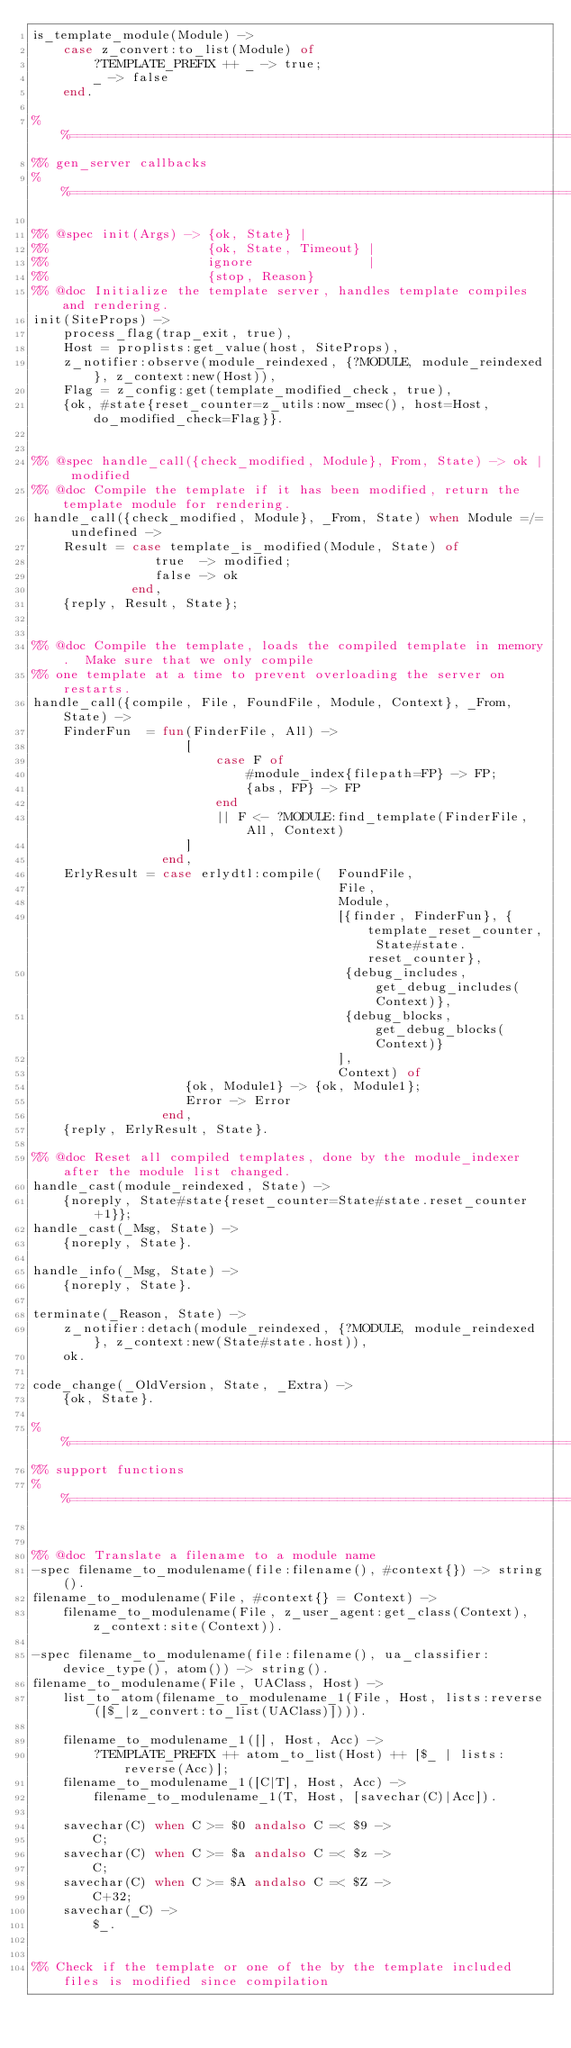<code> <loc_0><loc_0><loc_500><loc_500><_Erlang_>is_template_module(Module) ->
    case z_convert:to_list(Module) of
        ?TEMPLATE_PREFIX ++ _ -> true;
        _ -> false
    end.

%%====================================================================
%% gen_server callbacks
%%====================================================================

%% @spec init(Args) -> {ok, State} |
%%                     {ok, State, Timeout} |
%%                     ignore               |
%%                     {stop, Reason}
%% @doc Initialize the template server, handles template compiles and rendering.
init(SiteProps) ->
    process_flag(trap_exit, true),
    Host = proplists:get_value(host, SiteProps),
    z_notifier:observe(module_reindexed, {?MODULE, module_reindexed}, z_context:new(Host)),
    Flag = z_config:get(template_modified_check, true),
    {ok, #state{reset_counter=z_utils:now_msec(), host=Host, do_modified_check=Flag}}.


%% @spec handle_call({check_modified, Module}, From, State) -> ok | modified
%% @doc Compile the template if it has been modified, return the template module for rendering.
handle_call({check_modified, Module}, _From, State) when Module =/= undefined ->
    Result = case template_is_modified(Module, State) of
                true  -> modified;
                false -> ok
             end,
    {reply, Result, State};


%% @doc Compile the template, loads the compiled template in memory.  Make sure that we only compile 
%% one template at a time to prevent overloading the server on restarts.
handle_call({compile, File, FoundFile, Module, Context}, _From, State) ->
    FinderFun  = fun(FinderFile, All) ->
                    [
                        case F of
                            #module_index{filepath=FP} -> FP;
                            {abs, FP} -> FP
                        end
                        || F <- ?MODULE:find_template(FinderFile, All, Context)
                    ]
                 end,
    ErlyResult = case erlydtl:compile(  FoundFile,
                                        File,
                                        Module, 
                                        [{finder, FinderFun}, {template_reset_counter, State#state.reset_counter},
                                         {debug_includes, get_debug_includes(Context)},
                                         {debug_blocks, get_debug_blocks(Context)}
                                        ],
                                        Context) of
                    {ok, Module1} -> {ok, Module1};
                    Error -> Error
                 end,
    {reply, ErlyResult, State}.

%% @doc Reset all compiled templates, done by the module_indexer after the module list changed.
handle_cast(module_reindexed, State) -> 
    {noreply, State#state{reset_counter=State#state.reset_counter+1}};
handle_cast(_Msg, State) -> 
    {noreply, State}.

handle_info(_Msg, State) -> 
    {noreply, State}.

terminate(_Reason, State) ->
    z_notifier:detach(module_reindexed, {?MODULE, module_reindexed}, z_context:new(State#state.host)),
    ok.

code_change(_OldVersion, State, _Extra) ->
    {ok, State}.

%%====================================================================
%% support functions
%%====================================================================


%% @doc Translate a filename to a module name
-spec filename_to_modulename(file:filename(), #context{}) -> string().
filename_to_modulename(File, #context{} = Context) ->
    filename_to_modulename(File, z_user_agent:get_class(Context), z_context:site(Context)).

-spec filename_to_modulename(file:filename(), ua_classifier:device_type(), atom()) -> string().
filename_to_modulename(File, UAClass, Host) ->
    list_to_atom(filename_to_modulename_1(File, Host, lists:reverse([$_|z_convert:to_list(UAClass)]))).

    filename_to_modulename_1([], Host, Acc) ->
        ?TEMPLATE_PREFIX ++ atom_to_list(Host) ++ [$_ | lists:reverse(Acc)];
    filename_to_modulename_1([C|T], Host, Acc) ->
        filename_to_modulename_1(T, Host, [savechar(C)|Acc]).

    savechar(C) when C >= $0 andalso C =< $9 ->
        C;
    savechar(C) when C >= $a andalso C =< $z ->
        C;
    savechar(C) when C >= $A andalso C =< $Z ->
        C+32;
    savechar(_C) ->
        $_.


%% Check if the template or one of the by the template included files is modified since compilation</code> 